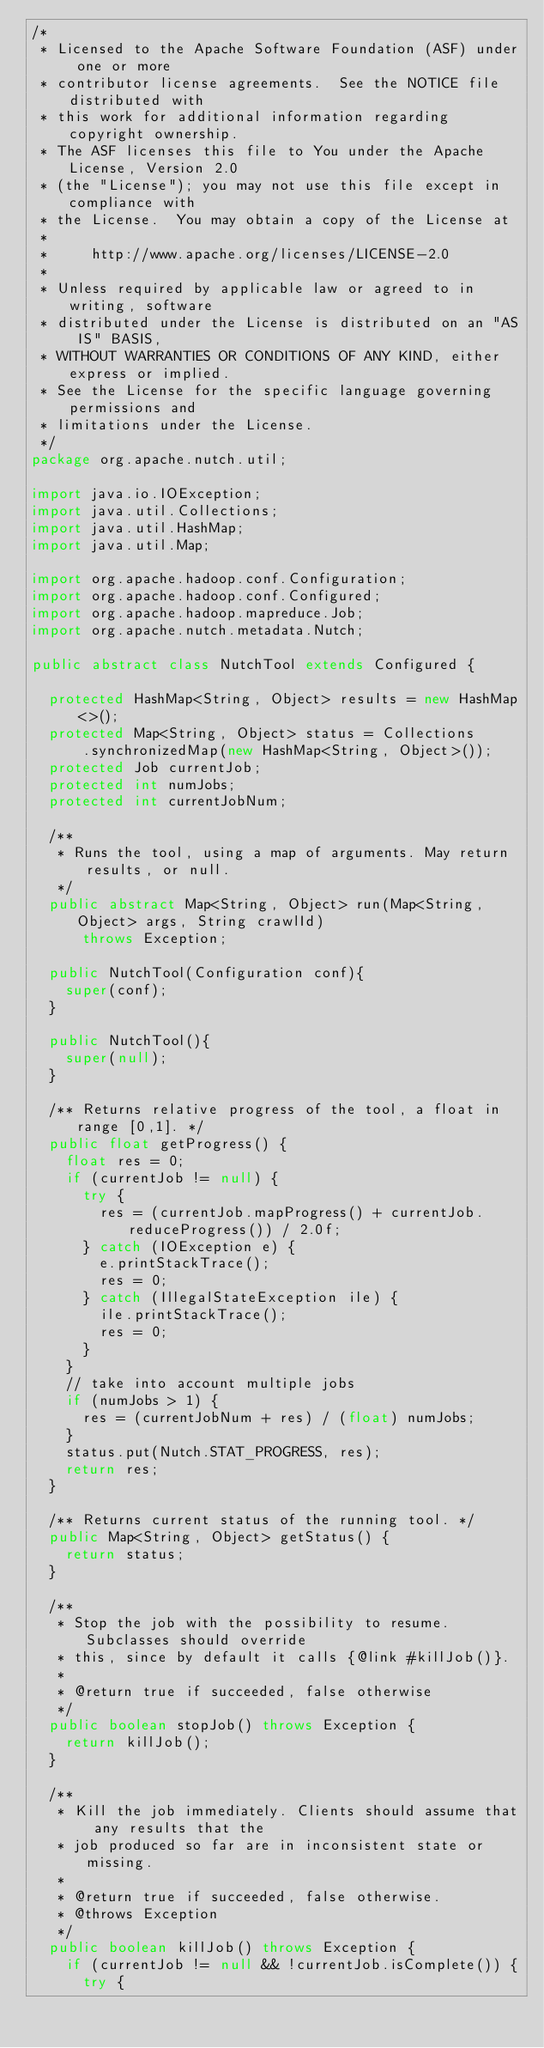<code> <loc_0><loc_0><loc_500><loc_500><_Java_>/*
 * Licensed to the Apache Software Foundation (ASF) under one or more
 * contributor license agreements.  See the NOTICE file distributed with
 * this work for additional information regarding copyright ownership.
 * The ASF licenses this file to You under the Apache License, Version 2.0
 * (the "License"); you may not use this file except in compliance with
 * the License.  You may obtain a copy of the License at
 *
 *     http://www.apache.org/licenses/LICENSE-2.0
 *
 * Unless required by applicable law or agreed to in writing, software
 * distributed under the License is distributed on an "AS IS" BASIS,
 * WITHOUT WARRANTIES OR CONDITIONS OF ANY KIND, either express or implied.
 * See the License for the specific language governing permissions and
 * limitations under the License.
 */
package org.apache.nutch.util;

import java.io.IOException;
import java.util.Collections;
import java.util.HashMap;
import java.util.Map;

import org.apache.hadoop.conf.Configuration;
import org.apache.hadoop.conf.Configured;
import org.apache.hadoop.mapreduce.Job;
import org.apache.nutch.metadata.Nutch;

public abstract class NutchTool extends Configured {

  protected HashMap<String, Object> results = new HashMap<>();
  protected Map<String, Object> status = Collections
      .synchronizedMap(new HashMap<String, Object>());
  protected Job currentJob;
  protected int numJobs;
  protected int currentJobNum;

  /**
   * Runs the tool, using a map of arguments. May return results, or null.
   */
  public abstract Map<String, Object> run(Map<String, Object> args, String crawlId)
      throws Exception;

  public NutchTool(Configuration conf){
    super(conf);
  }

  public NutchTool(){
    super(null);
  }

  /** Returns relative progress of the tool, a float in range [0,1]. */
  public float getProgress() {
    float res = 0;
    if (currentJob != null) {
      try {
        res = (currentJob.mapProgress() + currentJob.reduceProgress()) / 2.0f;
      } catch (IOException e) {
        e.printStackTrace();
        res = 0;
      } catch (IllegalStateException ile) {
        ile.printStackTrace();
        res = 0;
      }
    }
    // take into account multiple jobs
    if (numJobs > 1) {
      res = (currentJobNum + res) / (float) numJobs;
    }
    status.put(Nutch.STAT_PROGRESS, res);
    return res;
  }

  /** Returns current status of the running tool. */
  public Map<String, Object> getStatus() {
    return status;
  }

  /**
   * Stop the job with the possibility to resume. Subclasses should override
   * this, since by default it calls {@link #killJob()}.
   * 
   * @return true if succeeded, false otherwise
   */
  public boolean stopJob() throws Exception {
    return killJob();
  }

  /**
   * Kill the job immediately. Clients should assume that any results that the
   * job produced so far are in inconsistent state or missing.
   * 
   * @return true if succeeded, false otherwise.
   * @throws Exception
   */
  public boolean killJob() throws Exception {
    if (currentJob != null && !currentJob.isComplete()) {
      try {</code> 